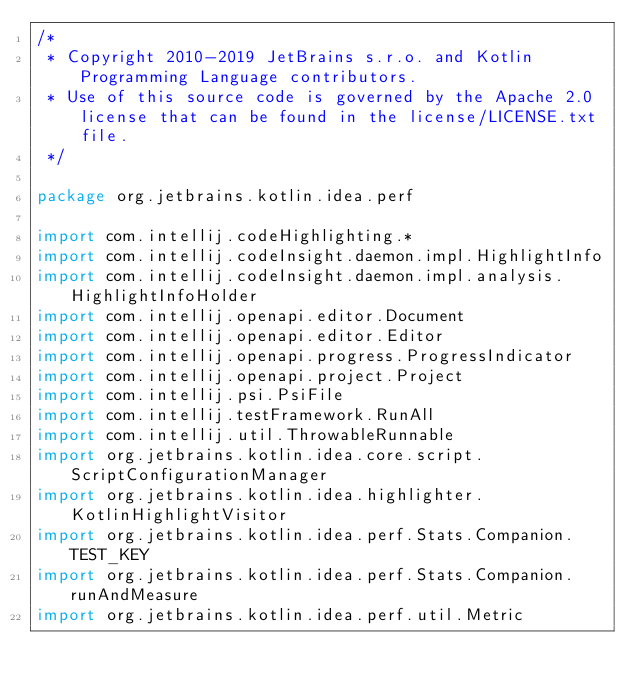<code> <loc_0><loc_0><loc_500><loc_500><_Kotlin_>/*
 * Copyright 2010-2019 JetBrains s.r.o. and Kotlin Programming Language contributors.
 * Use of this source code is governed by the Apache 2.0 license that can be found in the license/LICENSE.txt file.
 */

package org.jetbrains.kotlin.idea.perf

import com.intellij.codeHighlighting.*
import com.intellij.codeInsight.daemon.impl.HighlightInfo
import com.intellij.codeInsight.daemon.impl.analysis.HighlightInfoHolder
import com.intellij.openapi.editor.Document
import com.intellij.openapi.editor.Editor
import com.intellij.openapi.progress.ProgressIndicator
import com.intellij.openapi.project.Project
import com.intellij.psi.PsiFile
import com.intellij.testFramework.RunAll
import com.intellij.util.ThrowableRunnable
import org.jetbrains.kotlin.idea.core.script.ScriptConfigurationManager
import org.jetbrains.kotlin.idea.highlighter.KotlinHighlightVisitor
import org.jetbrains.kotlin.idea.perf.Stats.Companion.TEST_KEY
import org.jetbrains.kotlin.idea.perf.Stats.Companion.runAndMeasure
import org.jetbrains.kotlin.idea.perf.util.Metric</code> 